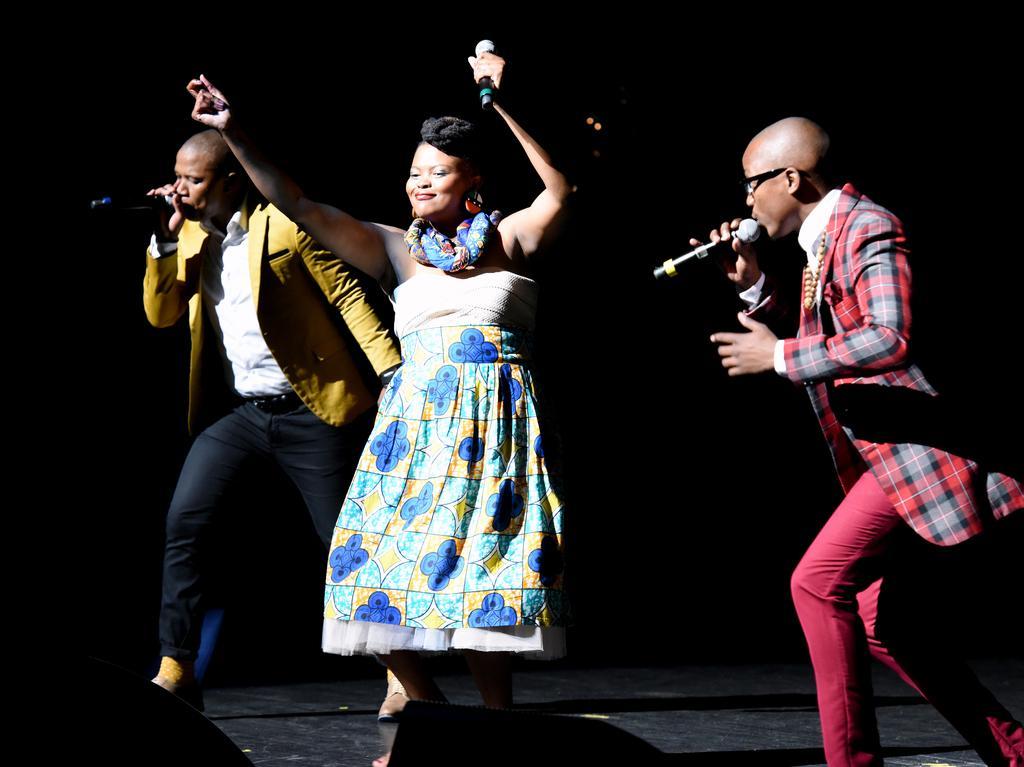Can you describe this image briefly? In this image I can see three persons standing and they are holding few microphones and I can see the dark background. 